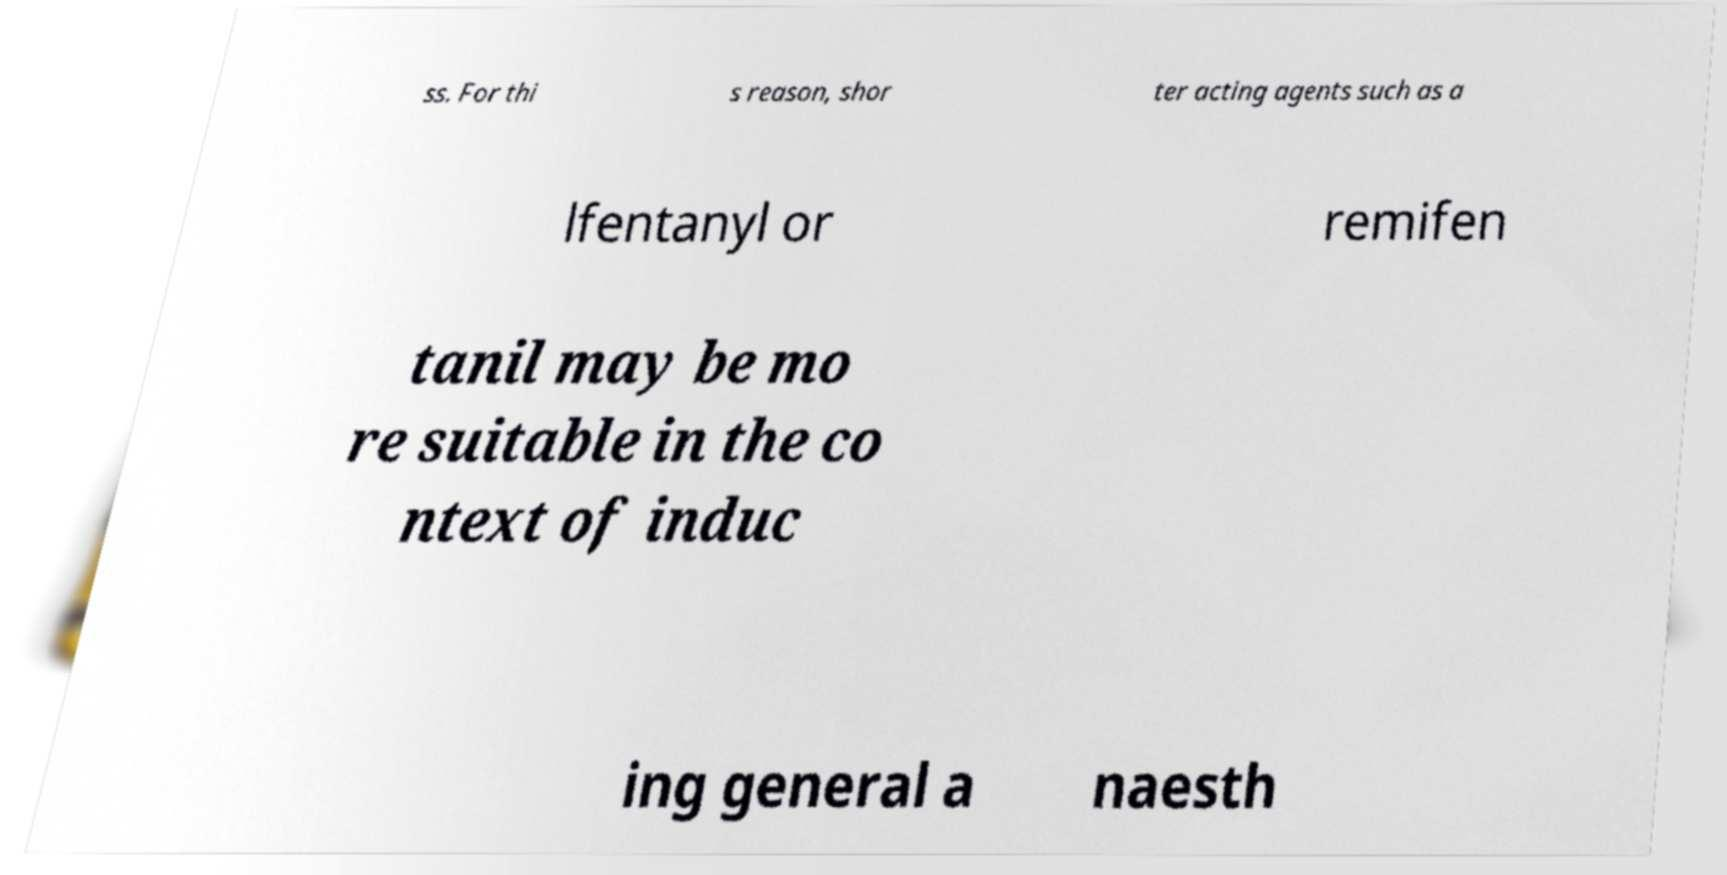Please identify and transcribe the text found in this image. ss. For thi s reason, shor ter acting agents such as a lfentanyl or remifen tanil may be mo re suitable in the co ntext of induc ing general a naesth 